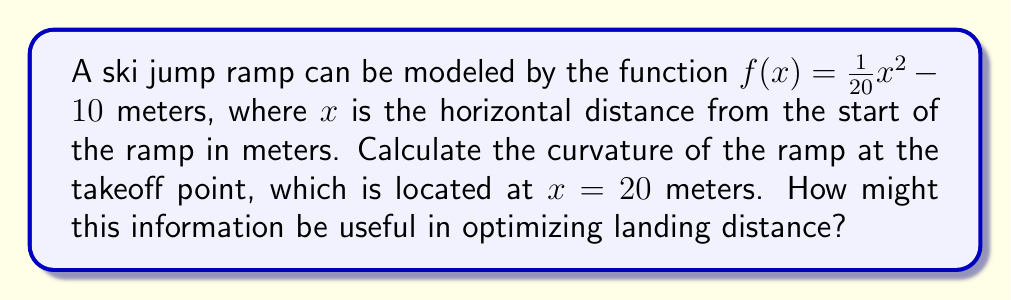What is the answer to this math problem? To find the curvature of the ski jump ramp, we'll follow these steps:

1) The formula for curvature $K$ is:

   $$K = \frac{|f''(x)|}{(1+(f'(x))^2)^{3/2}}$$

2) First, let's find $f'(x)$ and $f''(x)$:
   
   $f'(x) = \frac{1}{10}x$
   
   $f''(x) = \frac{1}{10}$

3) Now, we need to evaluate $f'(x)$ at $x=20$:
   
   $f'(20) = \frac{1}{10}(20) = 2$

4) Substituting these values into the curvature formula:

   $$K = \frac{|\frac{1}{10}|}{(1+(2)^2)^{3/2}}$$

5) Simplify:
   
   $$K = \frac{0.1}{(1+4)^{3/2}} = \frac{0.1}{5^{3/2}} = \frac{0.1}{5\sqrt{5}} = 0.00894$$

6) The curvature at the takeoff point is approximately 0.00894 m^(-1).

This information is useful for optimizing landing distance because:

1) The curvature affects the skier's trajectory at takeoff.
2) A lower curvature (flatter ramp) typically results in a longer jump.
3) However, the curvature also affects the skier's speed and ability to maintain balance.
4) By adjusting the curvature, designers can balance between maximizing distance and ensuring safe, controlled landings.
Answer: $K = 0.00894$ m^(-1) 